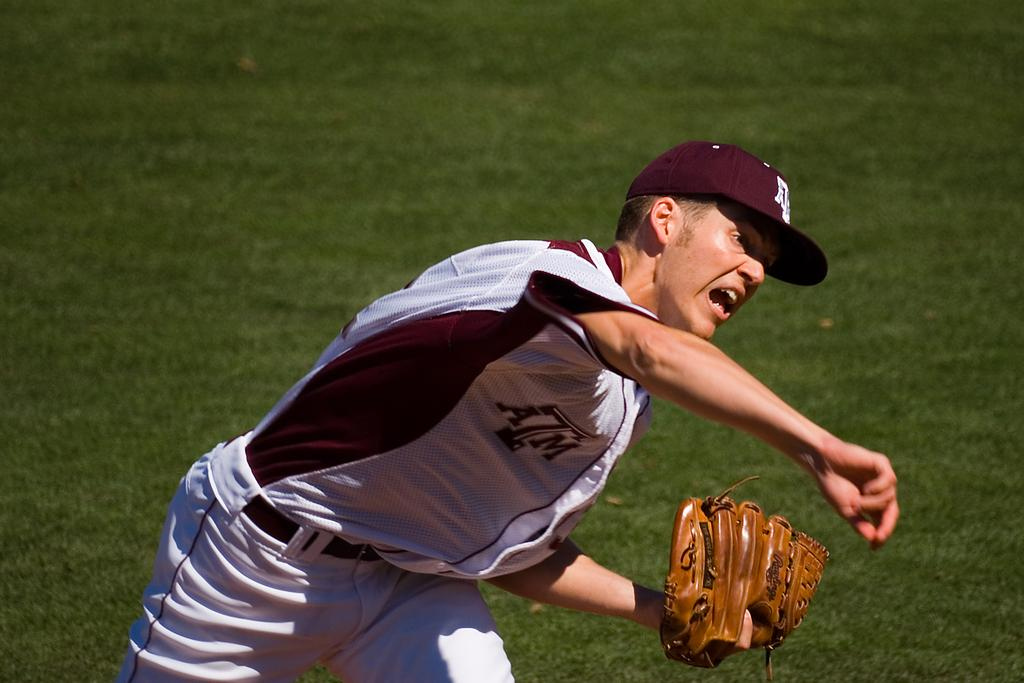Provide a one-sentence caption for the provided image. The pitcher for ATM just released the ball. 